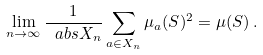<formula> <loc_0><loc_0><loc_500><loc_500>\lim _ { n \rightarrow \infty } \frac { 1 } { \ a b s { X _ { n } } } \sum _ { a \in X _ { n } } \mu _ { a } ( S ) ^ { 2 } = \mu ( S ) \, .</formula> 